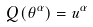Convert formula to latex. <formula><loc_0><loc_0><loc_500><loc_500>Q ( \theta ^ { \alpha } ) = u ^ { \alpha }</formula> 